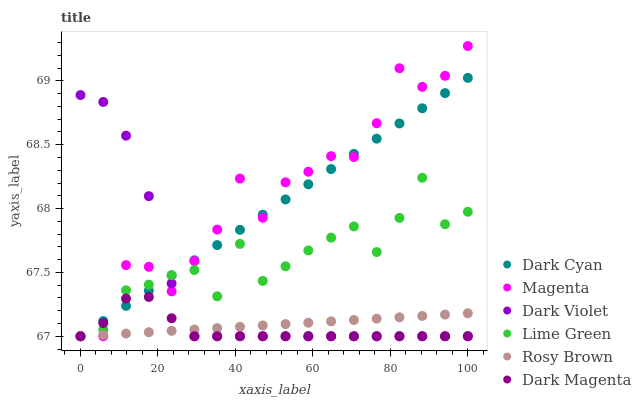Does Dark Magenta have the minimum area under the curve?
Answer yes or no. Yes. Does Magenta have the maximum area under the curve?
Answer yes or no. Yes. Does Rosy Brown have the minimum area under the curve?
Answer yes or no. No. Does Rosy Brown have the maximum area under the curve?
Answer yes or no. No. Is Rosy Brown the smoothest?
Answer yes or no. Yes. Is Magenta the roughest?
Answer yes or no. Yes. Is Dark Violet the smoothest?
Answer yes or no. No. Is Dark Violet the roughest?
Answer yes or no. No. Does Dark Magenta have the lowest value?
Answer yes or no. Yes. Does Magenta have the highest value?
Answer yes or no. Yes. Does Dark Violet have the highest value?
Answer yes or no. No. Does Dark Cyan intersect Rosy Brown?
Answer yes or no. Yes. Is Dark Cyan less than Rosy Brown?
Answer yes or no. No. Is Dark Cyan greater than Rosy Brown?
Answer yes or no. No. 